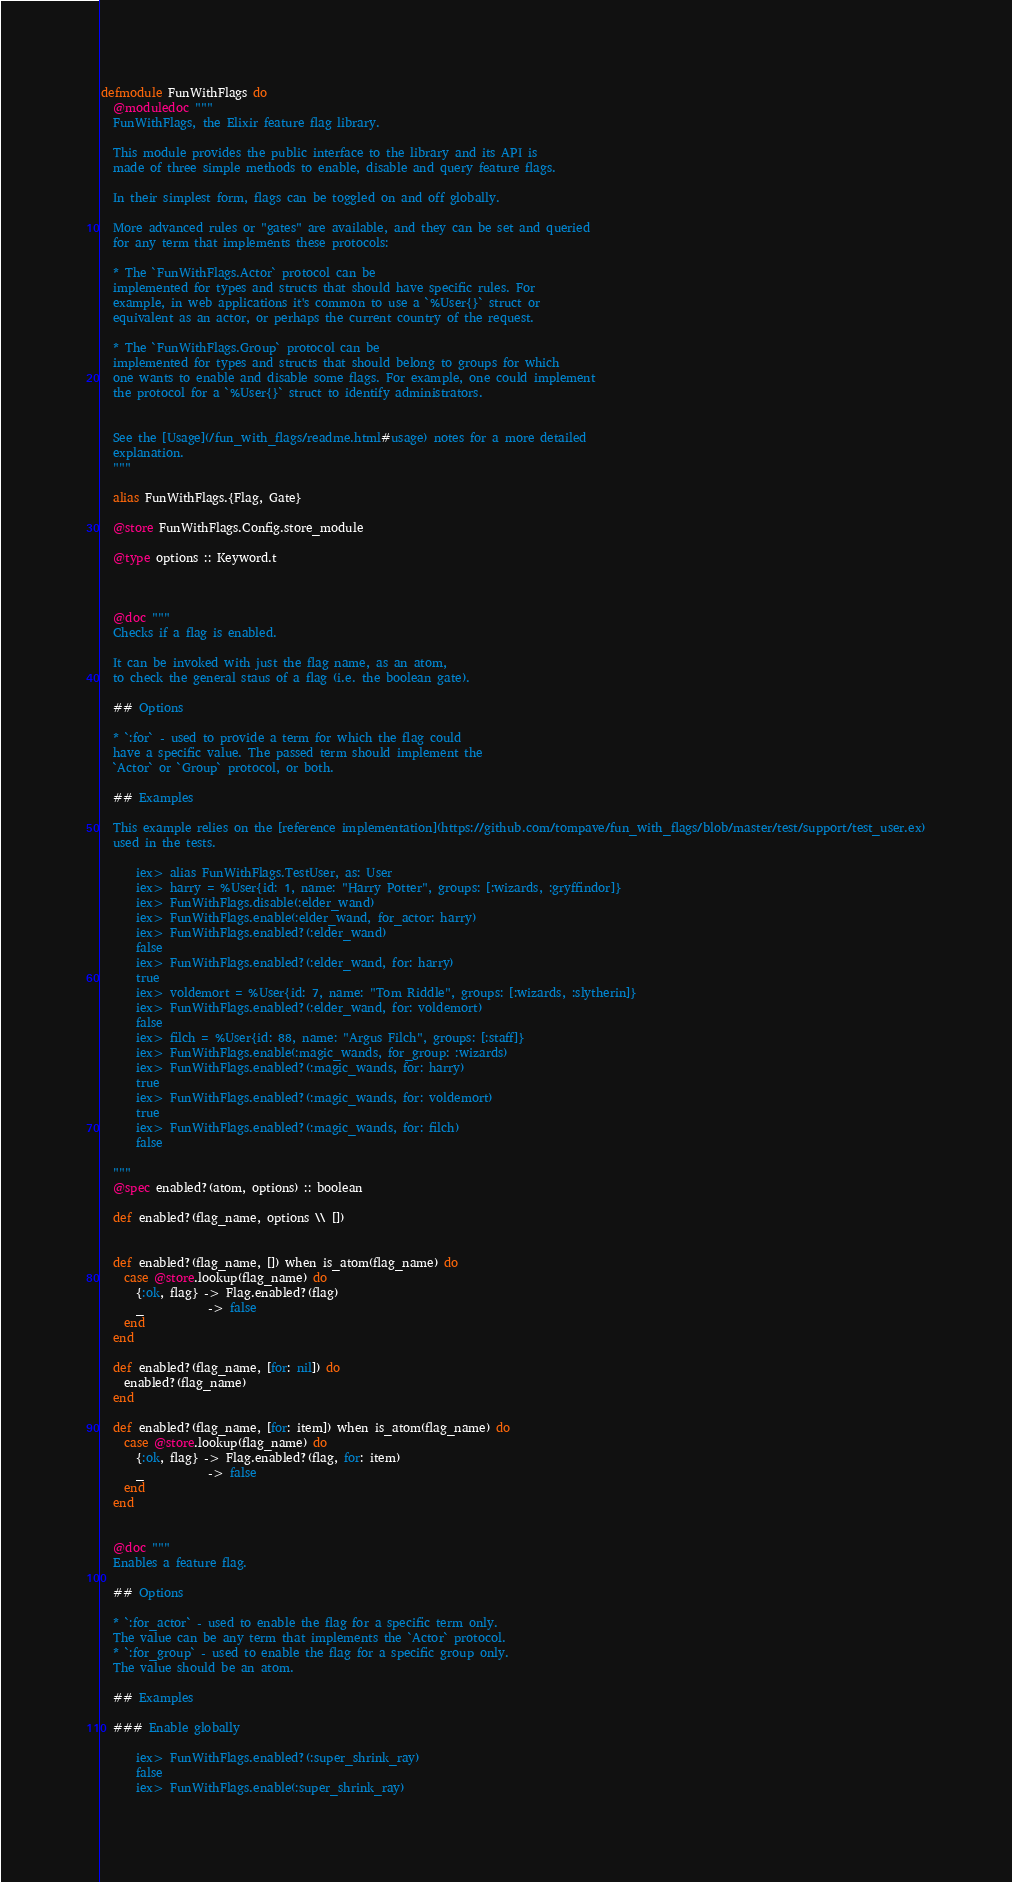Convert code to text. <code><loc_0><loc_0><loc_500><loc_500><_Elixir_>defmodule FunWithFlags do
  @moduledoc """
  FunWithFlags, the Elixir feature flag library.

  This module provides the public interface to the library and its API is
  made of three simple methods to enable, disable and query feature flags.

  In their simplest form, flags can be toggled on and off globally.

  More advanced rules or "gates" are available, and they can be set and queried
  for any term that implements these protocols:

  * The `FunWithFlags.Actor` protocol can be
  implemented for types and structs that should have specific rules. For
  example, in web applications it's common to use a `%User{}` struct or
  equivalent as an actor, or perhaps the current country of the request.

  * The `FunWithFlags.Group` protocol can be
  implemented for types and structs that should belong to groups for which
  one wants to enable and disable some flags. For example, one could implement
  the protocol for a `%User{}` struct to identify administrators.


  See the [Usage](/fun_with_flags/readme.html#usage) notes for a more detailed
  explanation.
  """

  alias FunWithFlags.{Flag, Gate}

  @store FunWithFlags.Config.store_module

  @type options :: Keyword.t



  @doc """
  Checks if a flag is enabled.

  It can be invoked with just the flag name, as an atom,
  to check the general staus of a flag (i.e. the boolean gate).

  ## Options

  * `:for` - used to provide a term for which the flag could
  have a specific value. The passed term should implement the
  `Actor` or `Group` protocol, or both.

  ## Examples

  This example relies on the [reference implementation](https://github.com/tompave/fun_with_flags/blob/master/test/support/test_user.ex)
  used in the tests.

      iex> alias FunWithFlags.TestUser, as: User
      iex> harry = %User{id: 1, name: "Harry Potter", groups: [:wizards, :gryffindor]}
      iex> FunWithFlags.disable(:elder_wand)
      iex> FunWithFlags.enable(:elder_wand, for_actor: harry)
      iex> FunWithFlags.enabled?(:elder_wand)
      false
      iex> FunWithFlags.enabled?(:elder_wand, for: harry)
      true
      iex> voldemort = %User{id: 7, name: "Tom Riddle", groups: [:wizards, :slytherin]}
      iex> FunWithFlags.enabled?(:elder_wand, for: voldemort)
      false
      iex> filch = %User{id: 88, name: "Argus Filch", groups: [:staff]}
      iex> FunWithFlags.enable(:magic_wands, for_group: :wizards)
      iex> FunWithFlags.enabled?(:magic_wands, for: harry)
      true
      iex> FunWithFlags.enabled?(:magic_wands, for: voldemort)
      true
      iex> FunWithFlags.enabled?(:magic_wands, for: filch)
      false

  """
  @spec enabled?(atom, options) :: boolean

  def enabled?(flag_name, options \\ [])


  def enabled?(flag_name, []) when is_atom(flag_name) do
    case @store.lookup(flag_name) do
      {:ok, flag} -> Flag.enabled?(flag)
      _           -> false
    end
  end

  def enabled?(flag_name, [for: nil]) do
    enabled?(flag_name)
  end

  def enabled?(flag_name, [for: item]) when is_atom(flag_name) do
    case @store.lookup(flag_name) do
      {:ok, flag} -> Flag.enabled?(flag, for: item)
      _           -> false
    end
  end


  @doc """
  Enables a feature flag.

  ## Options

  * `:for_actor` - used to enable the flag for a specific term only.
  The value can be any term that implements the `Actor` protocol.
  * `:for_group` - used to enable the flag for a specific group only.
  The value should be an atom.

  ## Examples

  ### Enable globally

      iex> FunWithFlags.enabled?(:super_shrink_ray)
      false
      iex> FunWithFlags.enable(:super_shrink_ray)</code> 